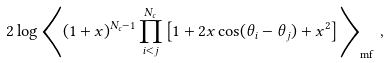Convert formula to latex. <formula><loc_0><loc_0><loc_500><loc_500>2 \log \left \langle ( 1 + x ) ^ { N _ { c } - 1 } \prod _ { i < j } ^ { N _ { c } } \left [ 1 + 2 x \cos ( \theta _ { i } - \theta _ { j } ) + x ^ { 2 } \right ] \right \rangle _ { \text {mf} } \, ,</formula> 